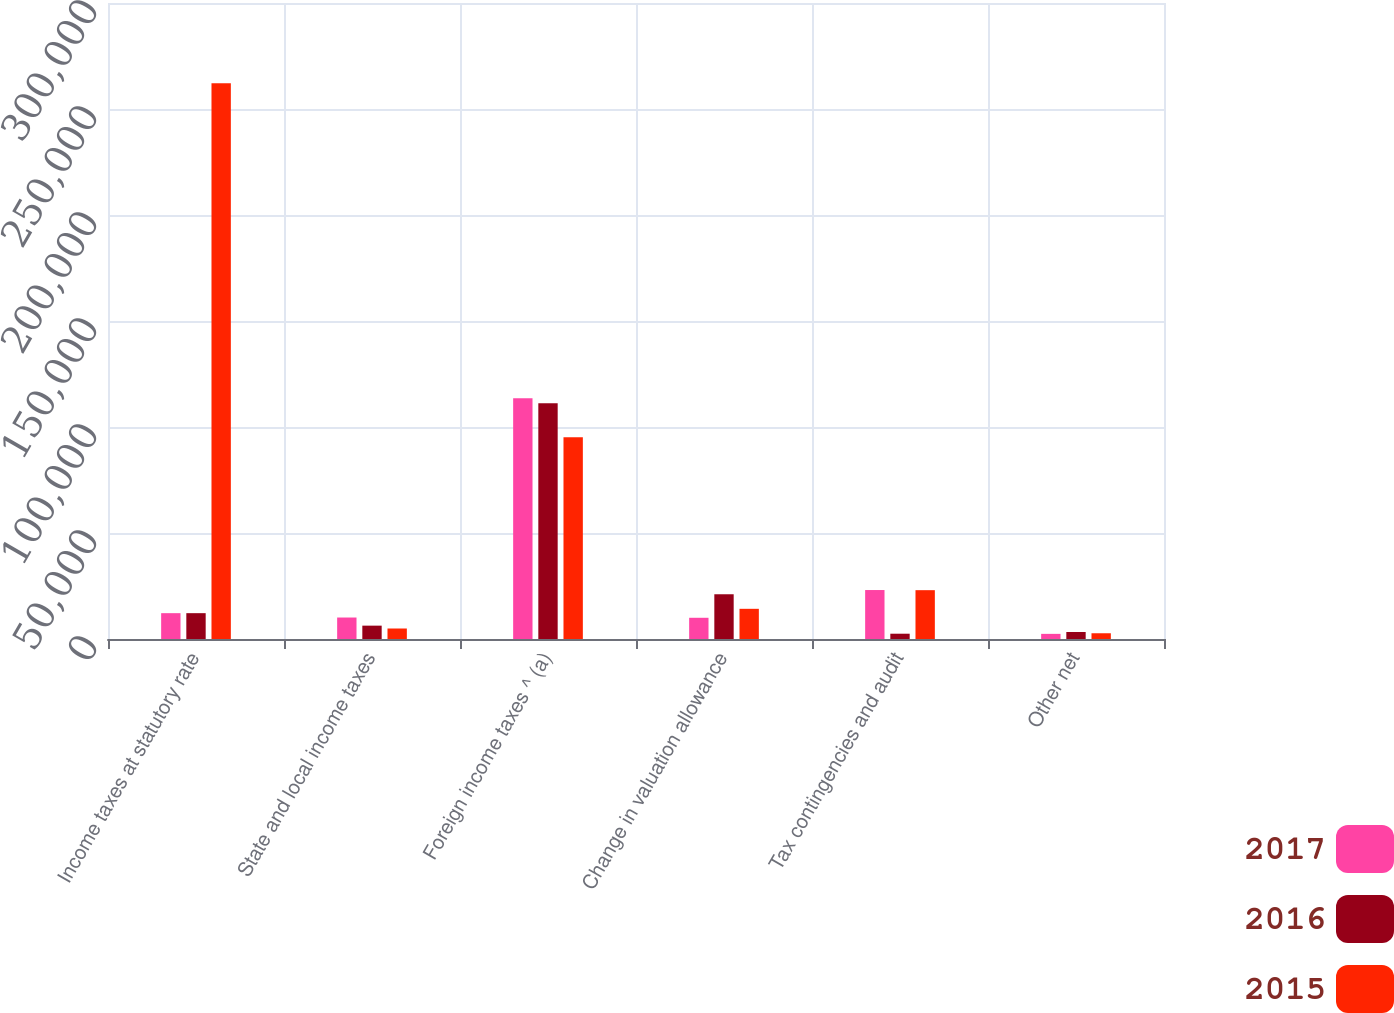Convert chart. <chart><loc_0><loc_0><loc_500><loc_500><stacked_bar_chart><ecel><fcel>Income taxes at statutory rate<fcel>State and local income taxes<fcel>Foreign income taxes ^ (a)<fcel>Change in valuation allowance<fcel>Tax contingencies and audit<fcel>Other net<nl><fcel>2017<fcel>12185<fcel>10133<fcel>113520<fcel>10008<fcel>23097<fcel>2422<nl><fcel>2016<fcel>12185<fcel>6298<fcel>111217<fcel>21106<fcel>2496<fcel>3306<nl><fcel>2015<fcel>262102<fcel>4951<fcel>95198<fcel>14237<fcel>23032<fcel>2711<nl></chart> 